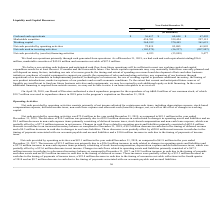According to Acacia Communications's financial document, What happened on April 30, 2018? Board of Directors authorized a stock repurchase program for the repurchase of up to $60.0 million of our common stock (in millions). The document states: "On April 30, 2018, our Board of Directors authorized a stock repurchase program for the repurchase of up to $60.0 million of our common stock, of whic..." Also, How much was used to repurchase shares in 2018? According to the financial document, $39.7 (in millions). The relevant text states: "$39.7 million was used to repurchase shares in 2018 prior to the program’s expiration on December 31, 2018..." Also, What are the 3 factors that affect future capital requirement? rate of revenue growth, the timing and extent of spending on research and development efforts and other business initiatives, purchases of capital equipment to support our growth, the expansion of sales and marketing activities, any expansion of our business through acquisitions of or investments in complementary products, technologies or businesses, the use of working capital to purchase additional inventory, the timing of new product introductions, market acceptance of our products and overall economic conditions.. The document states: "ned and will depend on many factors, including our rate of revenue growth, the timing and extent of spending on research and development efforts and o..." Also, can you calculate: What is the percentage increase in marketable securities from 2018 to 2019?  To answer this question, I need to perform calculations using the financial data. The calculation is: (434,761-339,424)/339,424 , which equals 28.09 (percentage). This is based on the information: "Marketable securities 434,761 339,424 297,115 Marketable securities 434,761 339,424 297,115..." The key data points involved are: 339,424, 434,761. Also, can you calculate: What is the percentage increase in working capital from 2017 to 2019? To answer this question, I need to perform calculations using the financial data. The calculation is: (368,912-361,621)/361,621, which equals 2.02 (percentage). This is based on the information: "Working capital 368,912 370,445 361,621 Working capital 368,912 370,445 361,621..." The key data points involved are: 361,621, 368,912. Also, What is the value of stock repurchase program for 2018? According to the financial document, 60.0 (in millions). The relevant text states: "k repurchase program for the repurchase of up to $60.0 million of our common stock, of which..." Also, can you calculate: What is the average Cash and cash equivalents between 2017 to 2019? To answer this question, I need to perform calculations using the financial data. The calculation is: ($36,617+$60,444+$67,495)/3, which equals 54852 (in thousands). This is based on the information: "Cash and cash equivalents $ 36,617 $ 60,444 $ 67,495 Cash and cash equivalents $ 36,617 $ 60,444 $ 67,495 Cash and cash equivalents $ 36,617 $ 60,444 $ 67,495..." The key data points involved are: 36,617, 60,444, 67,495. 